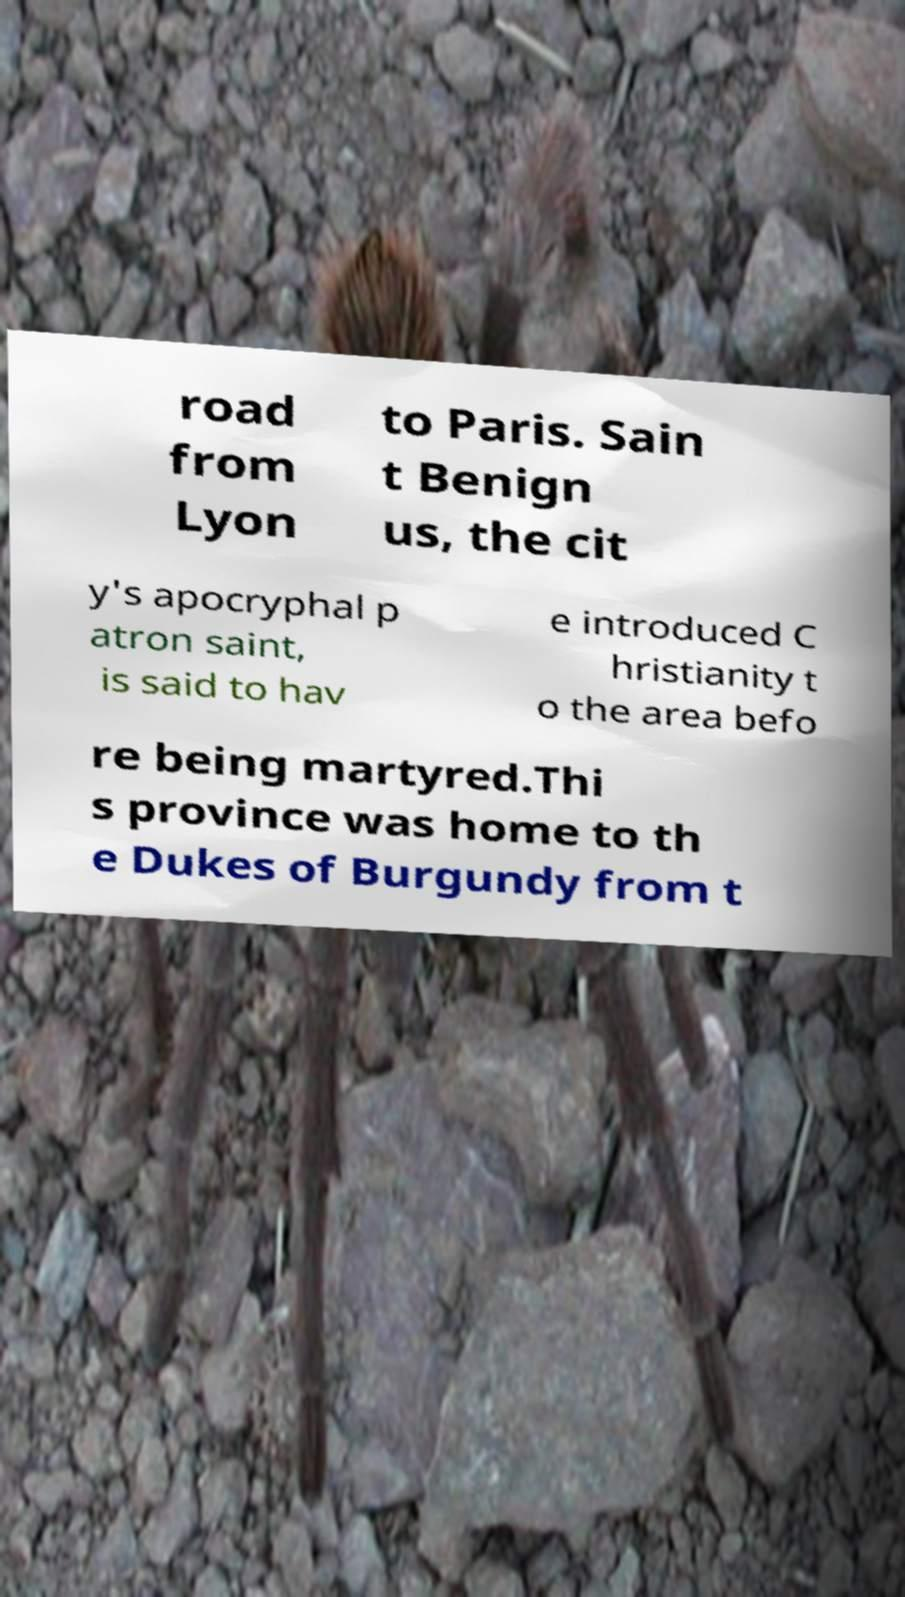I need the written content from this picture converted into text. Can you do that? road from Lyon to Paris. Sain t Benign us, the cit y's apocryphal p atron saint, is said to hav e introduced C hristianity t o the area befo re being martyred.Thi s province was home to th e Dukes of Burgundy from t 